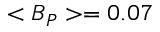<formula> <loc_0><loc_0><loc_500><loc_500>< B _ { P } > = 0 . 0 7</formula> 